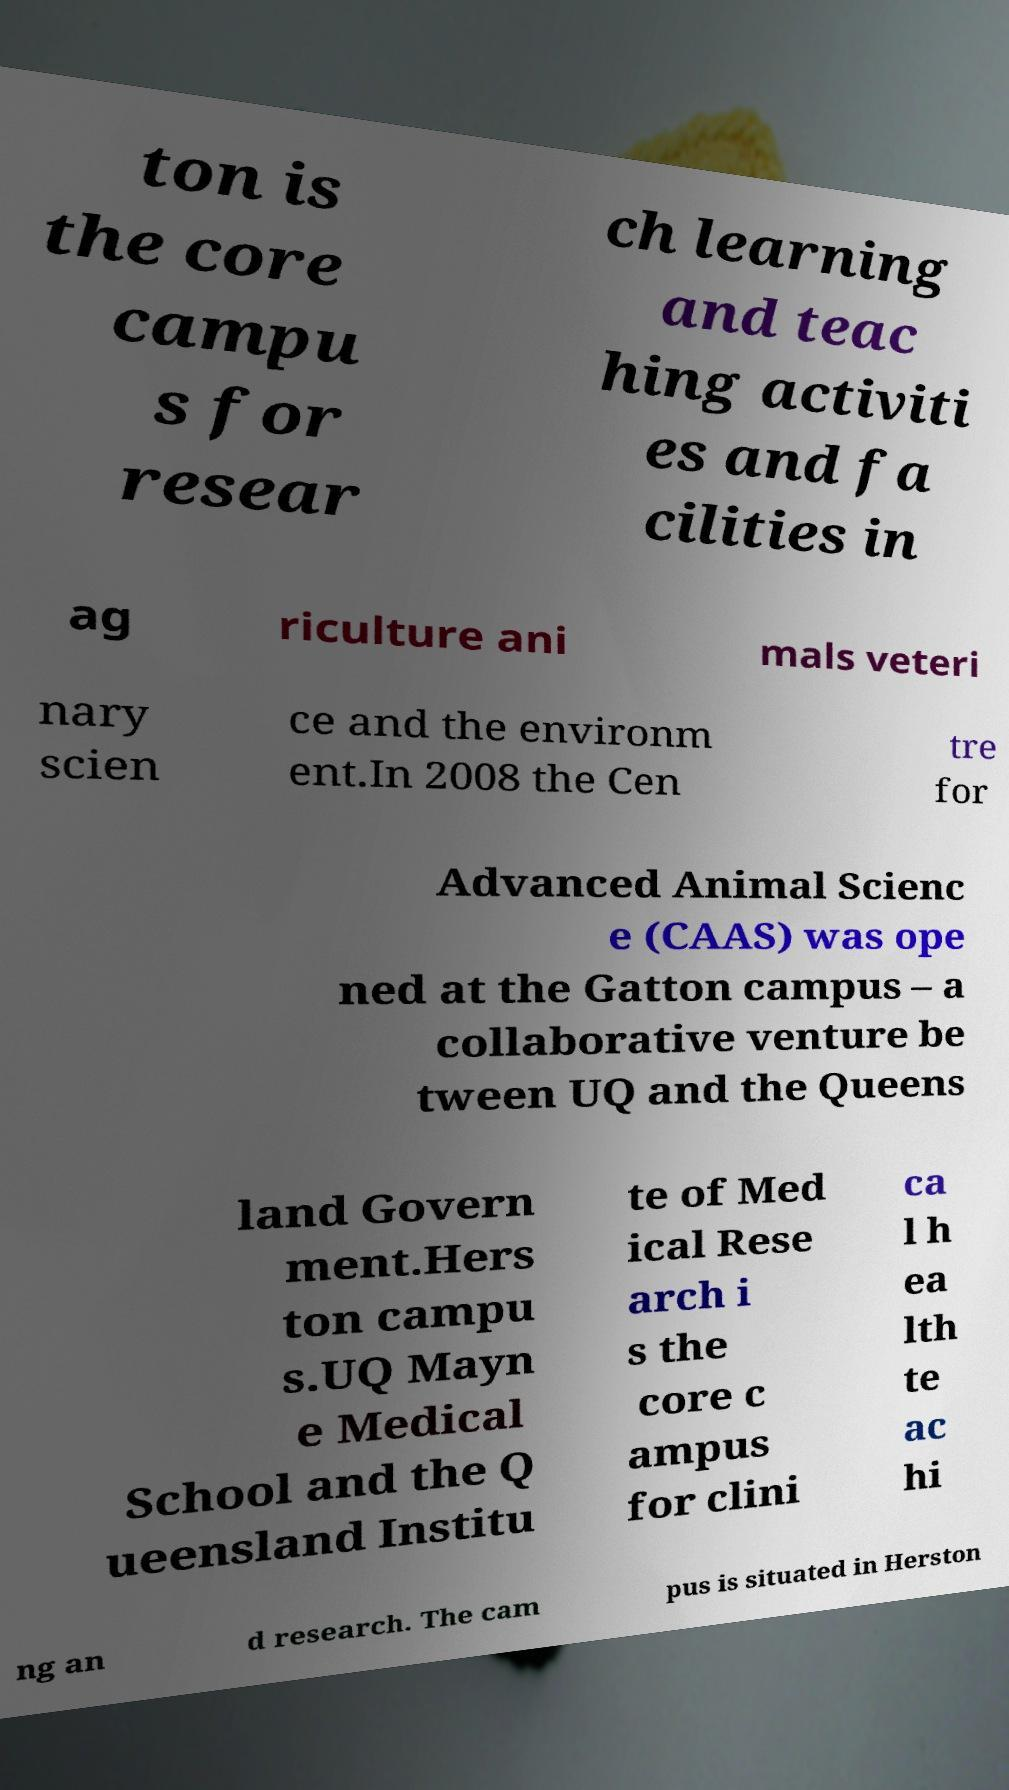Please identify and transcribe the text found in this image. ton is the core campu s for resear ch learning and teac hing activiti es and fa cilities in ag riculture ani mals veteri nary scien ce and the environm ent.In 2008 the Cen tre for Advanced Animal Scienc e (CAAS) was ope ned at the Gatton campus – a collaborative venture be tween UQ and the Queens land Govern ment.Hers ton campu s.UQ Mayn e Medical School and the Q ueensland Institu te of Med ical Rese arch i s the core c ampus for clini ca l h ea lth te ac hi ng an d research. The cam pus is situated in Herston 